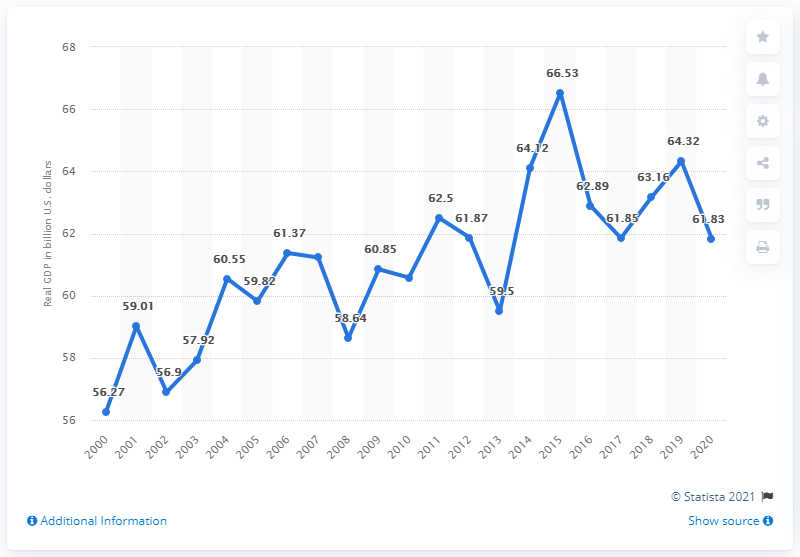Specify some key components in this picture. In the previous year, Delaware's GDP was 64.32 billion dollars. In 2020, the Gross Domestic Product (GDP) of Delaware was 61.83. 